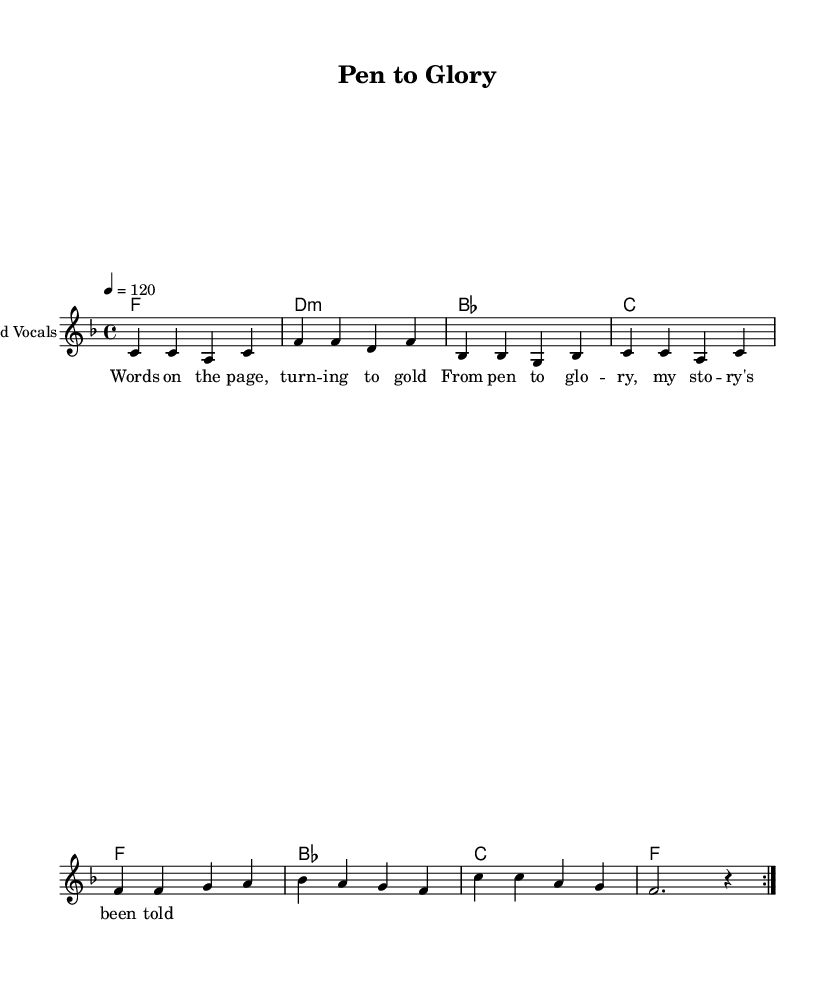What is the key signature of this music? The key signature is F major, which contains one flat (B flat). This is indicated at the beginning of the staff where the flats are placed.
Answer: F major What is the time signature of this music? The time signature is 4/4, shown at the beginning of the piece, indicating four beats in each measure.
Answer: 4/4 What is the tempo marking? The tempo marking is 120 beats per minute, specified by "4 = 120." This suggests a lively pace for the song.
Answer: 120 How many lines are in the lyric section? There are two lines of lyrics in the section, as shown by the positioning of the words beneath the melody notes. Counted as two full segments of text.
Answer: 2 What is the first word of the lyrics? The first word of the lyrics is "Words," which directly follows the opening of the lyric section. The first line starts with that word.
Answer: Words What type of music is this and what theme does it celebrate? This is a Soul anthem that celebrates literary success and recognition, as indicated by the title "Pen to Glory" which suggests a connection between writing and achievement.
Answer: Soul How many measures are in the repeated section? There are 8 measures in the repeated section, as the melody is marked to repeat twice (indicated by the volta sign) and each repeat consists of 4 measures.
Answer: 8 